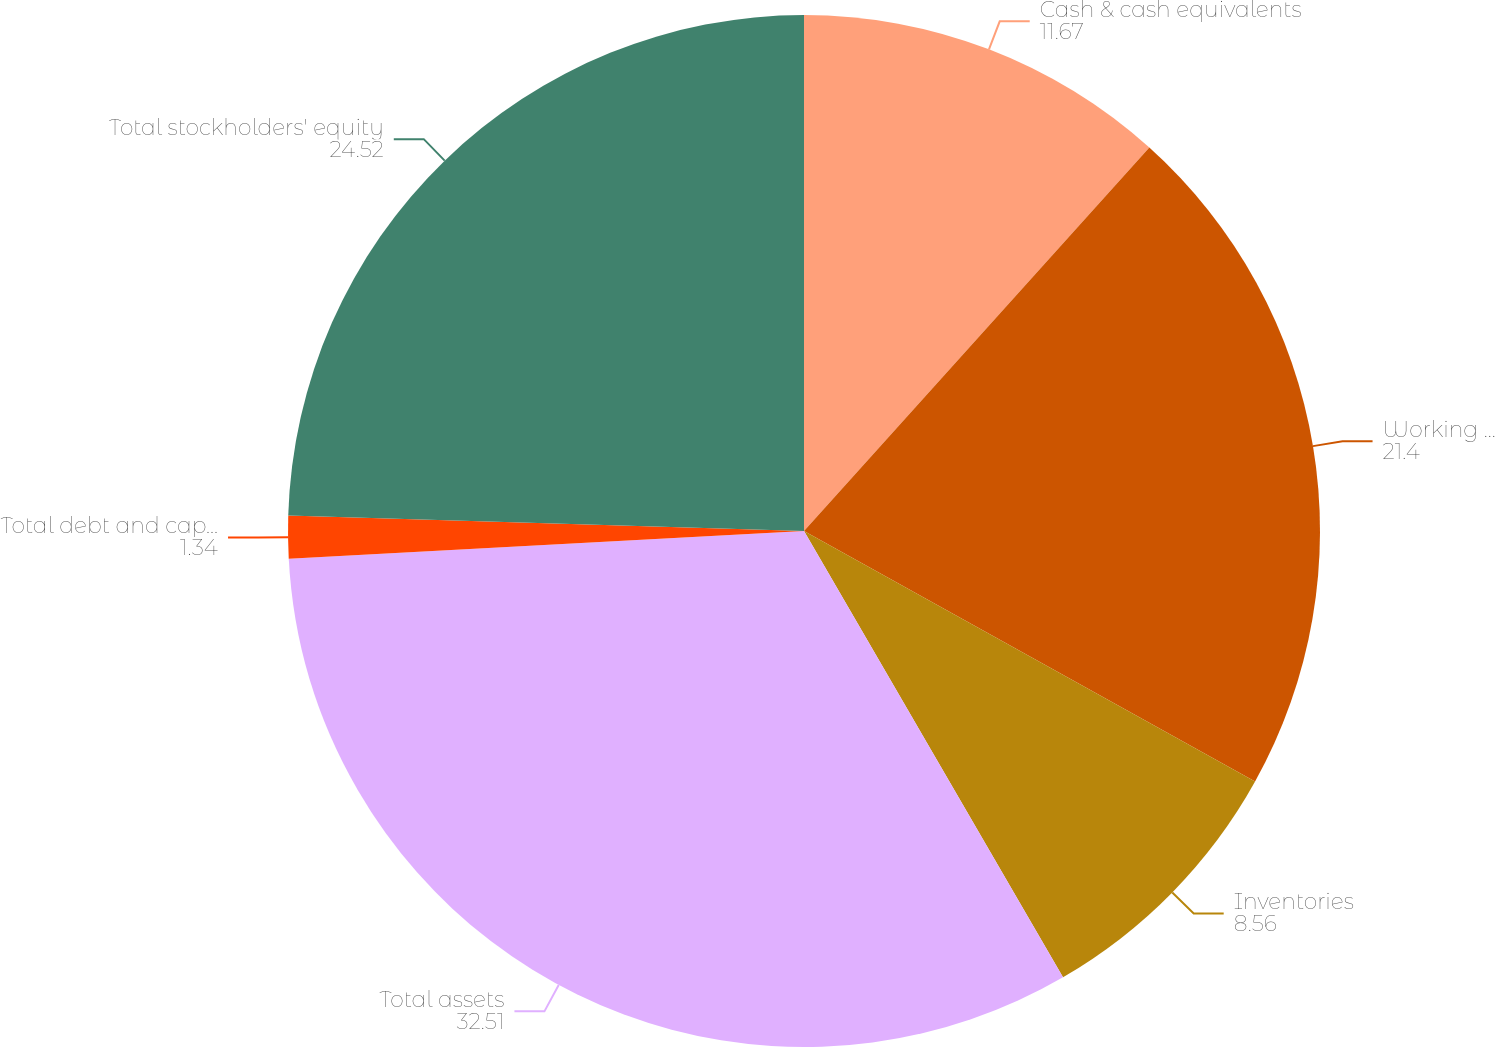Convert chart. <chart><loc_0><loc_0><loc_500><loc_500><pie_chart><fcel>Cash & cash equivalents<fcel>Working capital(2)<fcel>Inventories<fcel>Total assets<fcel>Total debt and capital lease<fcel>Total stockholders' equity<nl><fcel>11.67%<fcel>21.4%<fcel>8.56%<fcel>32.51%<fcel>1.34%<fcel>24.52%<nl></chart> 